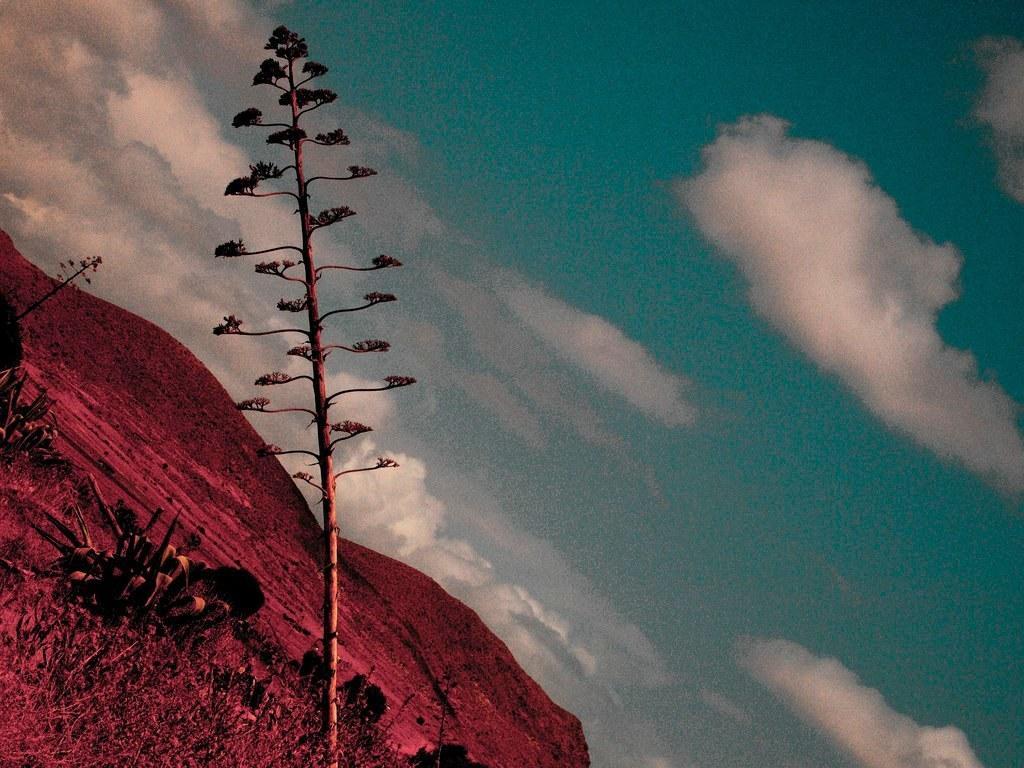How would you summarize this image in a sentence or two? In this image we can see some plants, grass and mountains, in the background we can see the sky with clouds. 